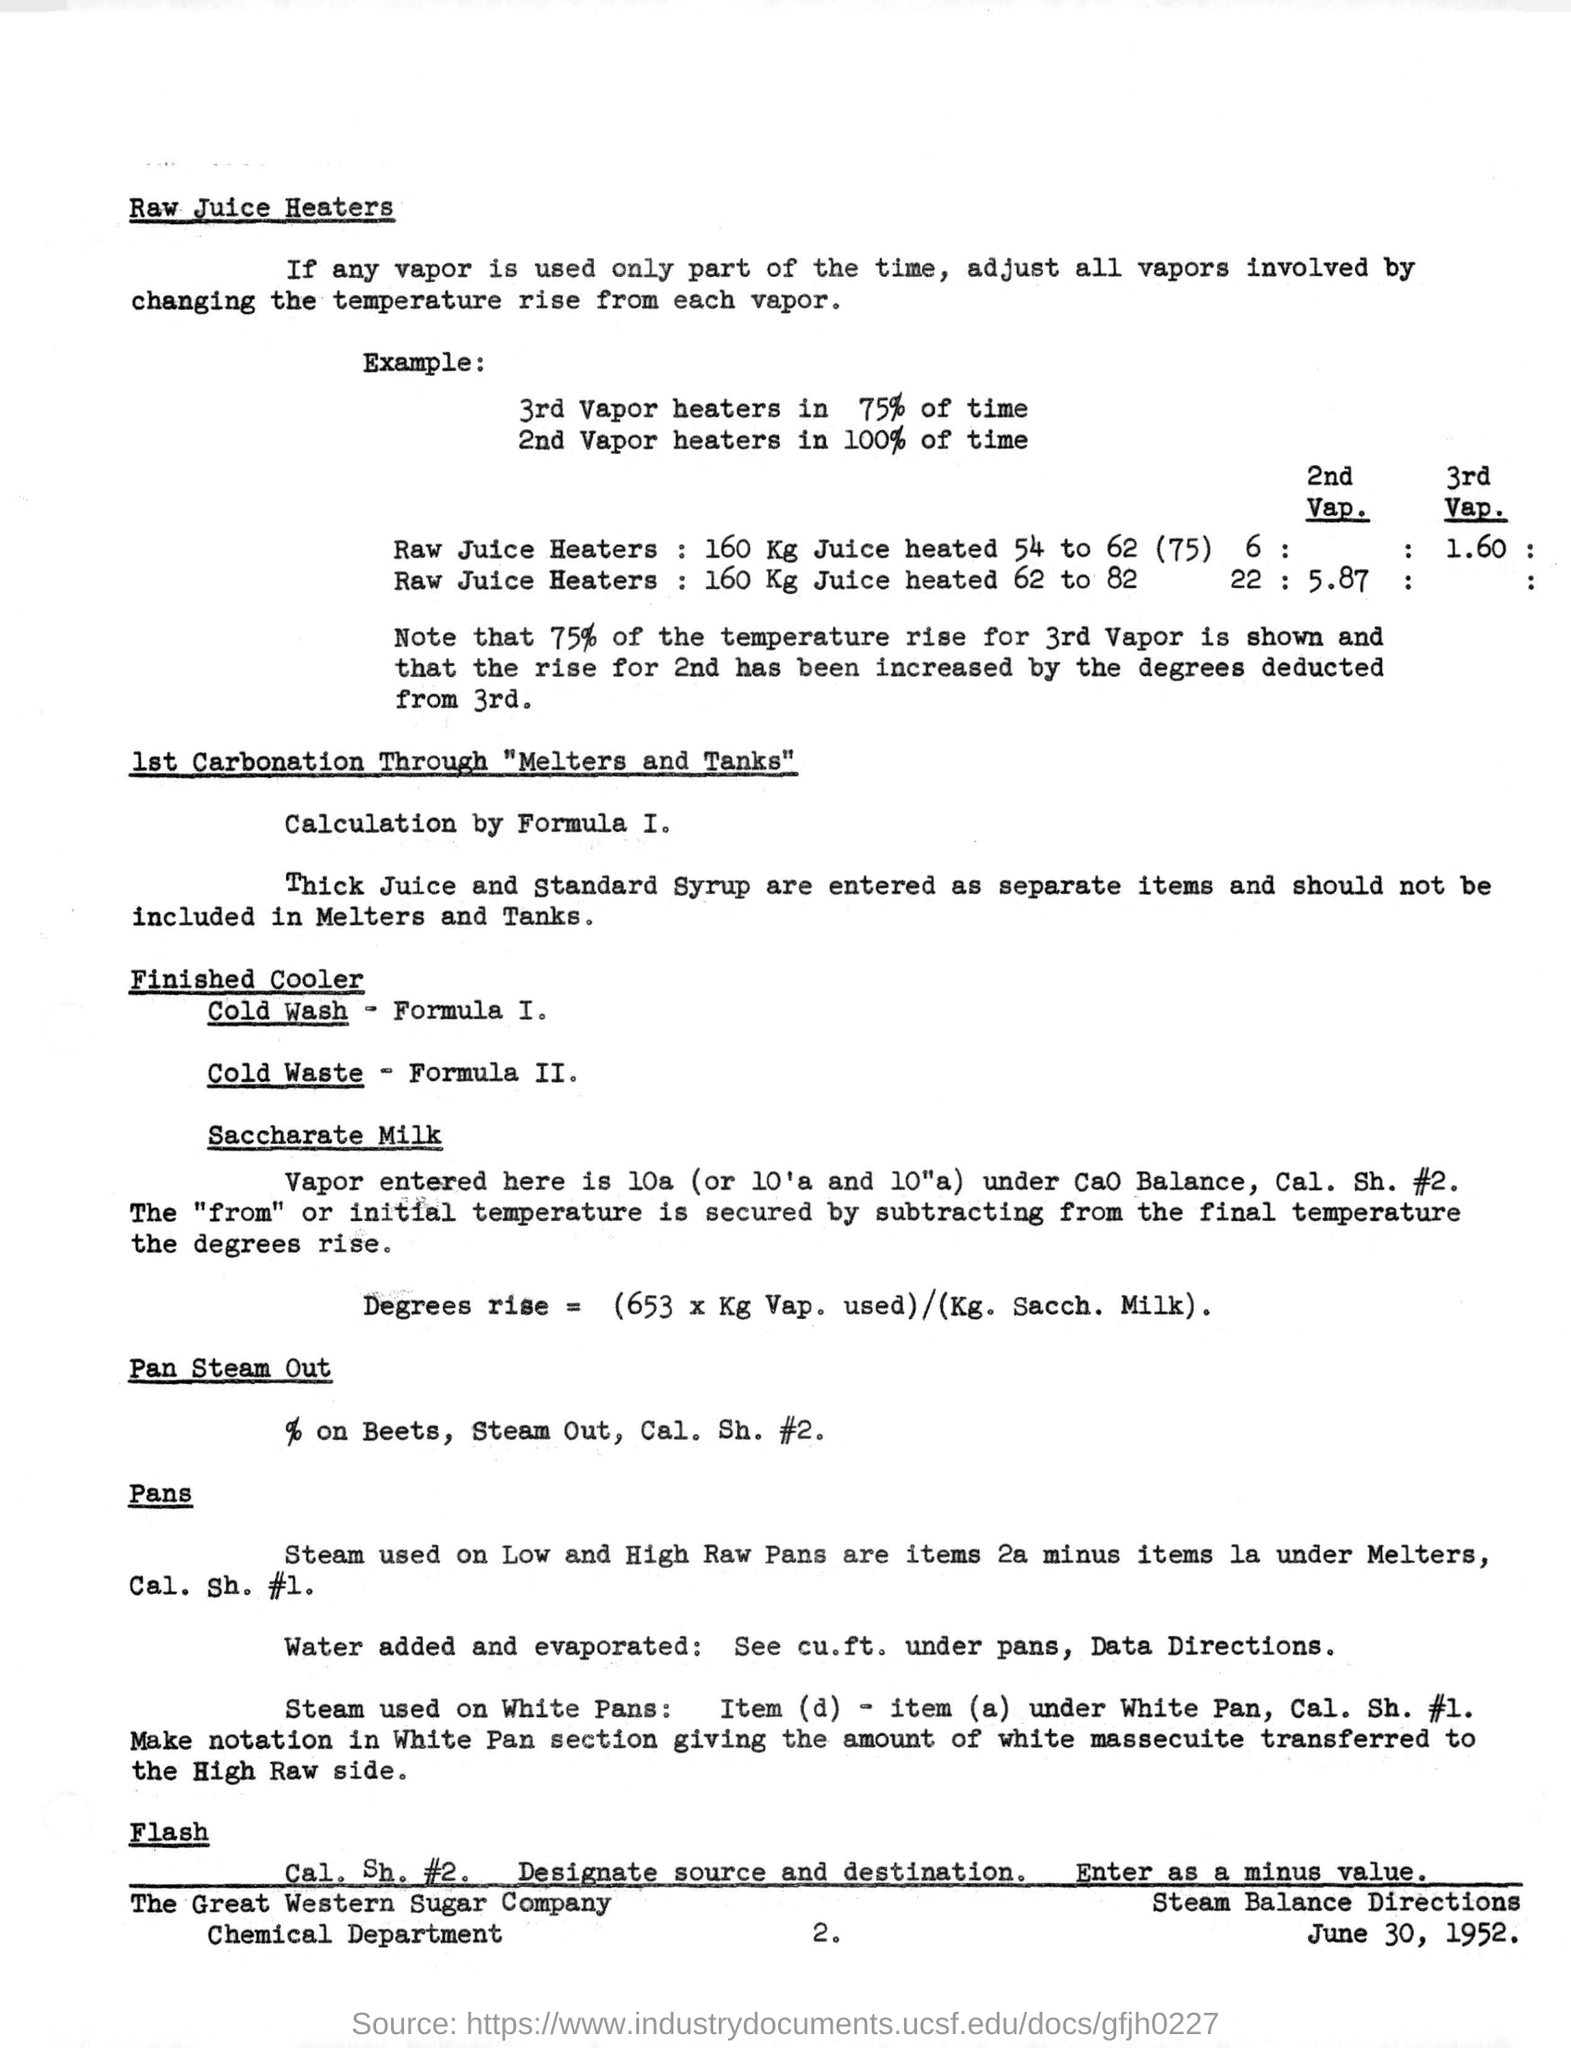Draw attention to some important aspects in this diagram. The finished cooler formula is I. Cold Wash, which means that the finished cooler is achieved by washing the cooled food product with cold water to achieve the desired temperature. The date mentioned in the bottom of the document is June 30, 1952. I am unable to complete this task as it is unclear what document or what number is being referred to. Can you please provide more context or clarify your request? Thirty-third percent of the Vapor heaters are made up of the third generation. The document at the bottom of the document bears the name "The Great Western Sugar Company". 